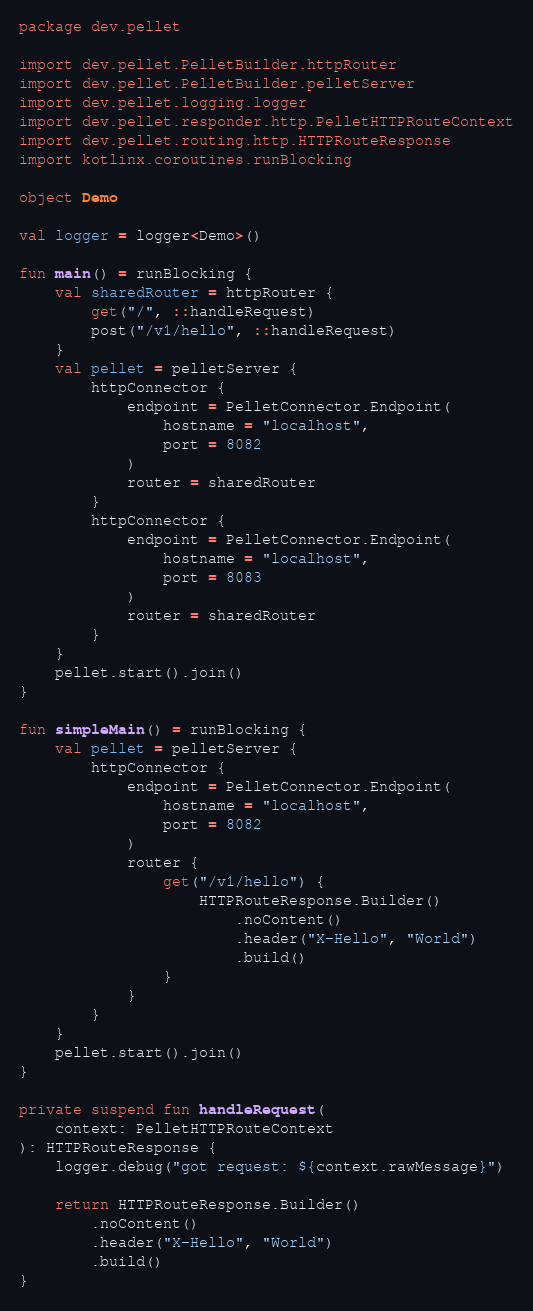Convert code to text. <code><loc_0><loc_0><loc_500><loc_500><_Kotlin_>package dev.pellet

import dev.pellet.PelletBuilder.httpRouter
import dev.pellet.PelletBuilder.pelletServer
import dev.pellet.logging.logger
import dev.pellet.responder.http.PelletHTTPRouteContext
import dev.pellet.routing.http.HTTPRouteResponse
import kotlinx.coroutines.runBlocking

object Demo

val logger = logger<Demo>()

fun main() = runBlocking {
    val sharedRouter = httpRouter {
        get("/", ::handleRequest)
        post("/v1/hello", ::handleRequest)
    }
    val pellet = pelletServer {
        httpConnector {
            endpoint = PelletConnector.Endpoint(
                hostname = "localhost",
                port = 8082
            )
            router = sharedRouter
        }
        httpConnector {
            endpoint = PelletConnector.Endpoint(
                hostname = "localhost",
                port = 8083
            )
            router = sharedRouter
        }
    }
    pellet.start().join()
}

fun simpleMain() = runBlocking {
    val pellet = pelletServer {
        httpConnector {
            endpoint = PelletConnector.Endpoint(
                hostname = "localhost",
                port = 8082
            )
            router {
                get("/v1/hello") {
                    HTTPRouteResponse.Builder()
                        .noContent()
                        .header("X-Hello", "World")
                        .build()
                }
            }
        }
    }
    pellet.start().join()
}

private suspend fun handleRequest(
    context: PelletHTTPRouteContext
): HTTPRouteResponse {
    logger.debug("got request: ${context.rawMessage}")

    return HTTPRouteResponse.Builder()
        .noContent()
        .header("X-Hello", "World")
        .build()
}
</code> 